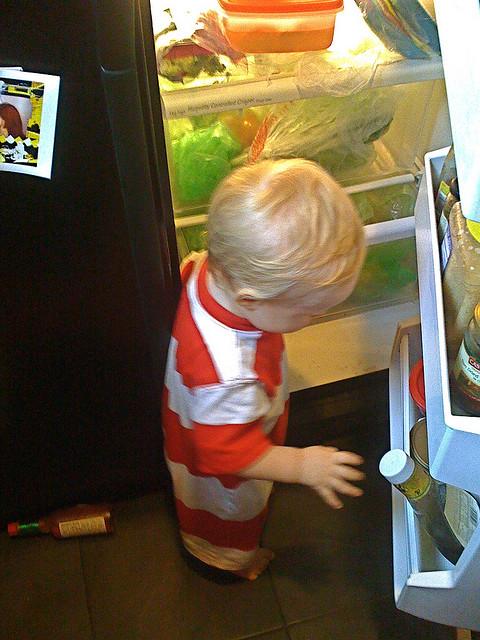Does this household have fixing for a salad?
Give a very brief answer. Yes. What is the kid reaching for?
Concise answer only. Salad dressing. Did the child open the door by himself?
Give a very brief answer. No. 